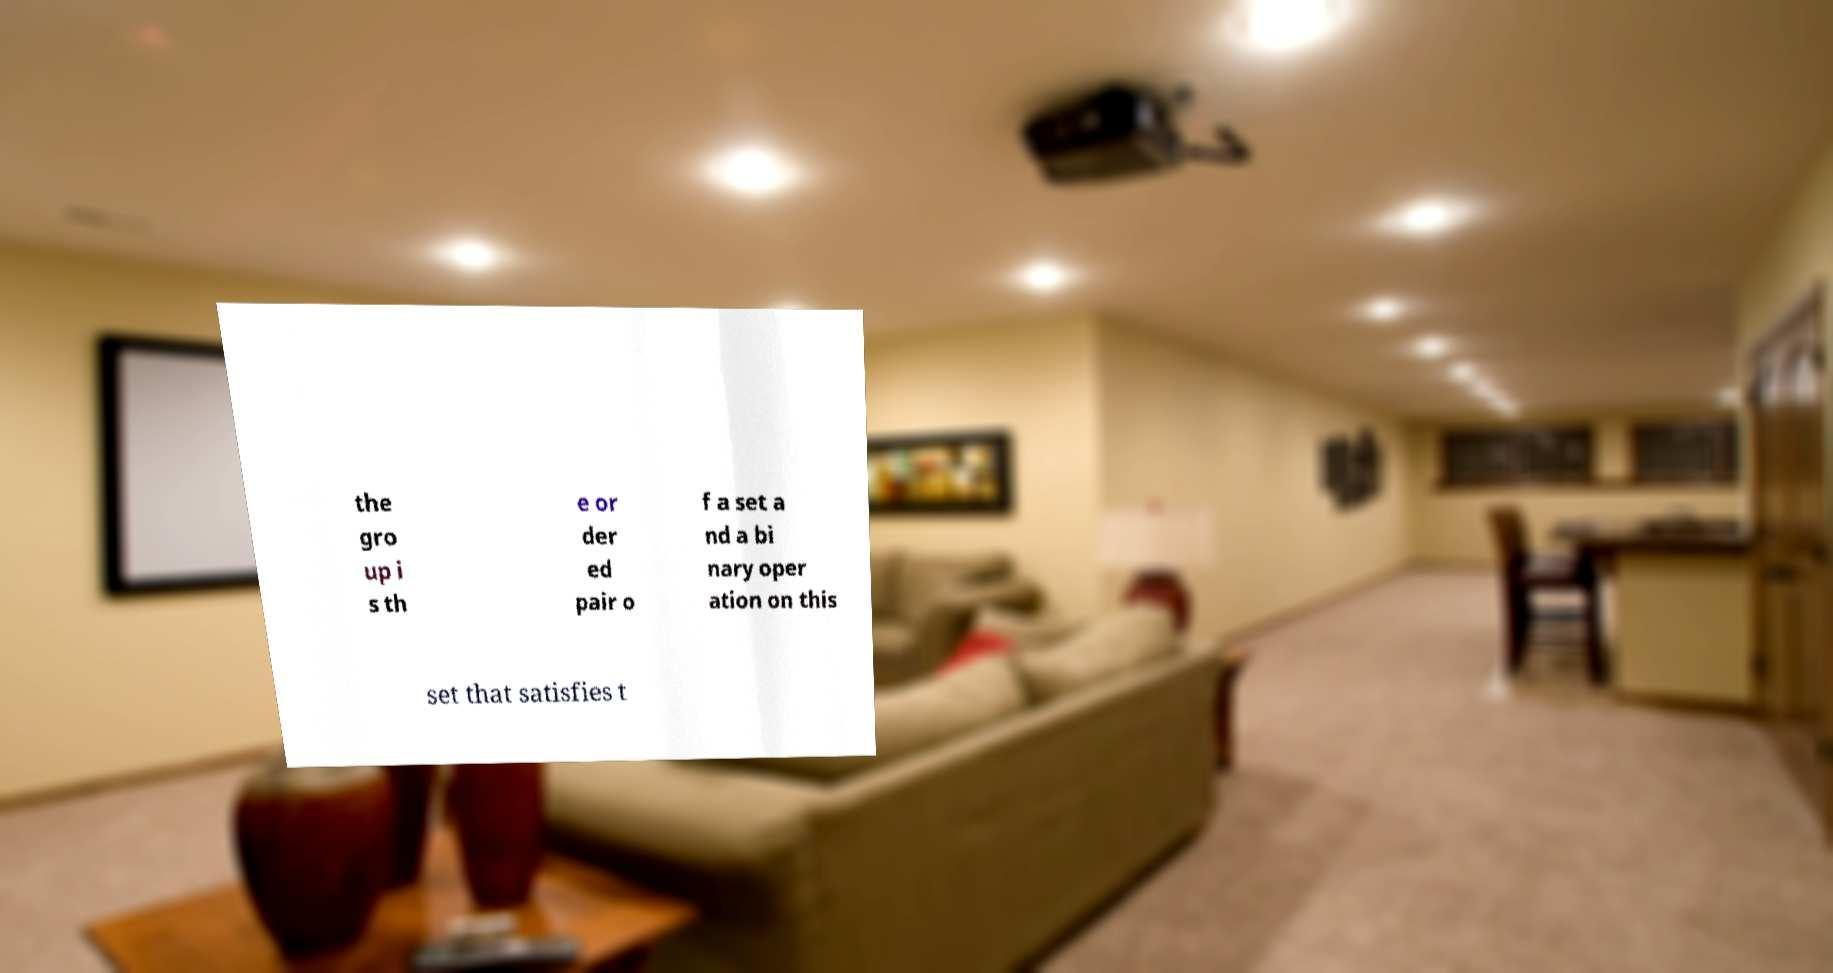I need the written content from this picture converted into text. Can you do that? the gro up i s th e or der ed pair o f a set a nd a bi nary oper ation on this set that satisfies t 